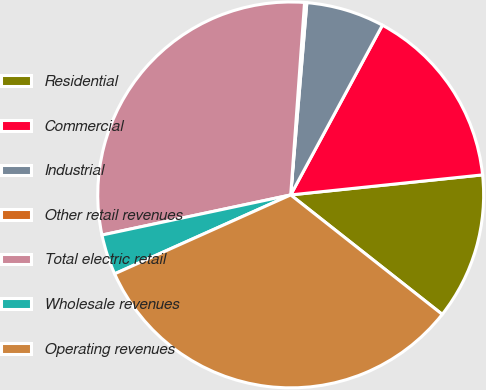Convert chart to OTSL. <chart><loc_0><loc_0><loc_500><loc_500><pie_chart><fcel>Residential<fcel>Commercial<fcel>Industrial<fcel>Other retail revenues<fcel>Total electric retail<fcel>Wholesale revenues<fcel>Operating revenues<nl><fcel>12.28%<fcel>15.46%<fcel>6.55%<fcel>0.19%<fcel>29.48%<fcel>3.37%<fcel>32.67%<nl></chart> 